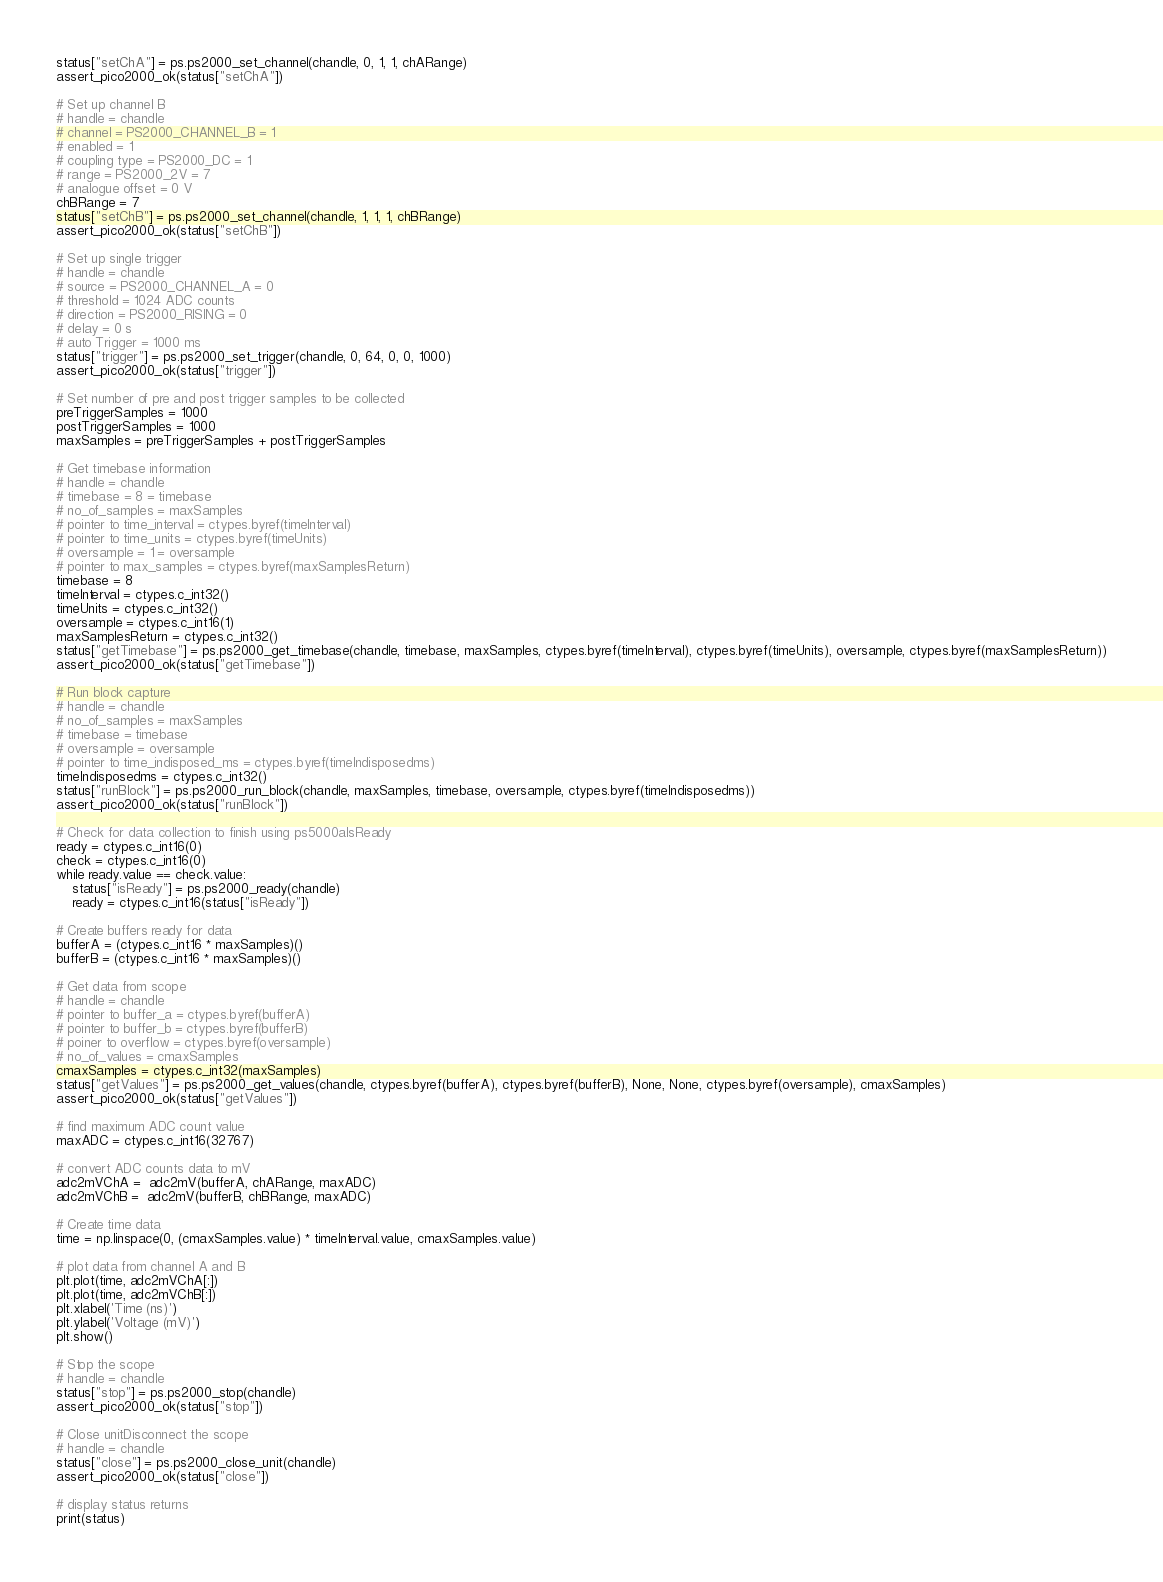<code> <loc_0><loc_0><loc_500><loc_500><_Python_>status["setChA"] = ps.ps2000_set_channel(chandle, 0, 1, 1, chARange)
assert_pico2000_ok(status["setChA"])

# Set up channel B
# handle = chandle
# channel = PS2000_CHANNEL_B = 1
# enabled = 1
# coupling type = PS2000_DC = 1
# range = PS2000_2V = 7
# analogue offset = 0 V
chBRange = 7
status["setChB"] = ps.ps2000_set_channel(chandle, 1, 1, 1, chBRange)
assert_pico2000_ok(status["setChB"])

# Set up single trigger
# handle = chandle
# source = PS2000_CHANNEL_A = 0
# threshold = 1024 ADC counts
# direction = PS2000_RISING = 0
# delay = 0 s
# auto Trigger = 1000 ms
status["trigger"] = ps.ps2000_set_trigger(chandle, 0, 64, 0, 0, 1000)
assert_pico2000_ok(status["trigger"])

# Set number of pre and post trigger samples to be collected
preTriggerSamples = 1000
postTriggerSamples = 1000
maxSamples = preTriggerSamples + postTriggerSamples

# Get timebase information
# handle = chandle
# timebase = 8 = timebase
# no_of_samples = maxSamples
# pointer to time_interval = ctypes.byref(timeInterval)
# pointer to time_units = ctypes.byref(timeUnits)
# oversample = 1 = oversample
# pointer to max_samples = ctypes.byref(maxSamplesReturn)
timebase = 8
timeInterval = ctypes.c_int32()
timeUnits = ctypes.c_int32()
oversample = ctypes.c_int16(1)
maxSamplesReturn = ctypes.c_int32()
status["getTimebase"] = ps.ps2000_get_timebase(chandle, timebase, maxSamples, ctypes.byref(timeInterval), ctypes.byref(timeUnits), oversample, ctypes.byref(maxSamplesReturn))
assert_pico2000_ok(status["getTimebase"])

# Run block capture
# handle = chandle
# no_of_samples = maxSamples
# timebase = timebase
# oversample = oversample
# pointer to time_indisposed_ms = ctypes.byref(timeIndisposedms)
timeIndisposedms = ctypes.c_int32()
status["runBlock"] = ps.ps2000_run_block(chandle, maxSamples, timebase, oversample, ctypes.byref(timeIndisposedms))
assert_pico2000_ok(status["runBlock"])

# Check for data collection to finish using ps5000aIsReady
ready = ctypes.c_int16(0)
check = ctypes.c_int16(0)
while ready.value == check.value:
    status["isReady"] = ps.ps2000_ready(chandle)
    ready = ctypes.c_int16(status["isReady"])

# Create buffers ready for data
bufferA = (ctypes.c_int16 * maxSamples)()
bufferB = (ctypes.c_int16 * maxSamples)()

# Get data from scope
# handle = chandle
# pointer to buffer_a = ctypes.byref(bufferA)
# pointer to buffer_b = ctypes.byref(bufferB)
# poiner to overflow = ctypes.byref(oversample)
# no_of_values = cmaxSamples
cmaxSamples = ctypes.c_int32(maxSamples)
status["getValues"] = ps.ps2000_get_values(chandle, ctypes.byref(bufferA), ctypes.byref(bufferB), None, None, ctypes.byref(oversample), cmaxSamples)
assert_pico2000_ok(status["getValues"])

# find maximum ADC count value
maxADC = ctypes.c_int16(32767)

# convert ADC counts data to mV
adc2mVChA =  adc2mV(bufferA, chARange, maxADC)
adc2mVChB =  adc2mV(bufferB, chBRange, maxADC)

# Create time data
time = np.linspace(0, (cmaxSamples.value) * timeInterval.value, cmaxSamples.value)

# plot data from channel A and B
plt.plot(time, adc2mVChA[:])
plt.plot(time, adc2mVChB[:])
plt.xlabel('Time (ns)')
plt.ylabel('Voltage (mV)')
plt.show()

# Stop the scope
# handle = chandle
status["stop"] = ps.ps2000_stop(chandle)
assert_pico2000_ok(status["stop"])

# Close unitDisconnect the scope
# handle = chandle
status["close"] = ps.ps2000_close_unit(chandle)
assert_pico2000_ok(status["close"])

# display status returns
print(status)
</code> 